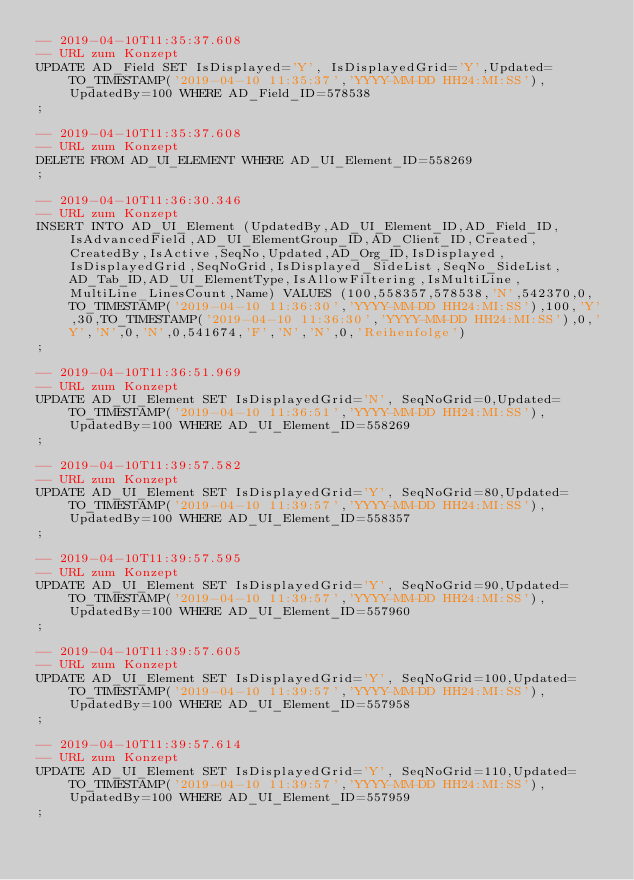<code> <loc_0><loc_0><loc_500><loc_500><_SQL_>-- 2019-04-10T11:35:37.608
-- URL zum Konzept
UPDATE AD_Field SET IsDisplayed='Y', IsDisplayedGrid='Y',Updated=TO_TIMESTAMP('2019-04-10 11:35:37','YYYY-MM-DD HH24:MI:SS'),UpdatedBy=100 WHERE AD_Field_ID=578538
;

-- 2019-04-10T11:35:37.608
-- URL zum Konzept
DELETE FROM AD_UI_ELEMENT WHERE AD_UI_Element_ID=558269
;

-- 2019-04-10T11:36:30.346
-- URL zum Konzept
INSERT INTO AD_UI_Element (UpdatedBy,AD_UI_Element_ID,AD_Field_ID,IsAdvancedField,AD_UI_ElementGroup_ID,AD_Client_ID,Created,CreatedBy,IsActive,SeqNo,Updated,AD_Org_ID,IsDisplayed,IsDisplayedGrid,SeqNoGrid,IsDisplayed_SideList,SeqNo_SideList,AD_Tab_ID,AD_UI_ElementType,IsAllowFiltering,IsMultiLine,MultiLine_LinesCount,Name) VALUES (100,558357,578538,'N',542370,0,TO_TIMESTAMP('2019-04-10 11:36:30','YYYY-MM-DD HH24:MI:SS'),100,'Y',30,TO_TIMESTAMP('2019-04-10 11:36:30','YYYY-MM-DD HH24:MI:SS'),0,'Y','N',0,'N',0,541674,'F','N','N',0,'Reihenfolge')
;

-- 2019-04-10T11:36:51.969
-- URL zum Konzept
UPDATE AD_UI_Element SET IsDisplayedGrid='N', SeqNoGrid=0,Updated=TO_TIMESTAMP('2019-04-10 11:36:51','YYYY-MM-DD HH24:MI:SS'),UpdatedBy=100 WHERE AD_UI_Element_ID=558269
;

-- 2019-04-10T11:39:57.582
-- URL zum Konzept
UPDATE AD_UI_Element SET IsDisplayedGrid='Y', SeqNoGrid=80,Updated=TO_TIMESTAMP('2019-04-10 11:39:57','YYYY-MM-DD HH24:MI:SS'),UpdatedBy=100 WHERE AD_UI_Element_ID=558357
;

-- 2019-04-10T11:39:57.595
-- URL zum Konzept
UPDATE AD_UI_Element SET IsDisplayedGrid='Y', SeqNoGrid=90,Updated=TO_TIMESTAMP('2019-04-10 11:39:57','YYYY-MM-DD HH24:MI:SS'),UpdatedBy=100 WHERE AD_UI_Element_ID=557960
;

-- 2019-04-10T11:39:57.605
-- URL zum Konzept
UPDATE AD_UI_Element SET IsDisplayedGrid='Y', SeqNoGrid=100,Updated=TO_TIMESTAMP('2019-04-10 11:39:57','YYYY-MM-DD HH24:MI:SS'),UpdatedBy=100 WHERE AD_UI_Element_ID=557958
;

-- 2019-04-10T11:39:57.614
-- URL zum Konzept
UPDATE AD_UI_Element SET IsDisplayedGrid='Y', SeqNoGrid=110,Updated=TO_TIMESTAMP('2019-04-10 11:39:57','YYYY-MM-DD HH24:MI:SS'),UpdatedBy=100 WHERE AD_UI_Element_ID=557959
;
</code> 